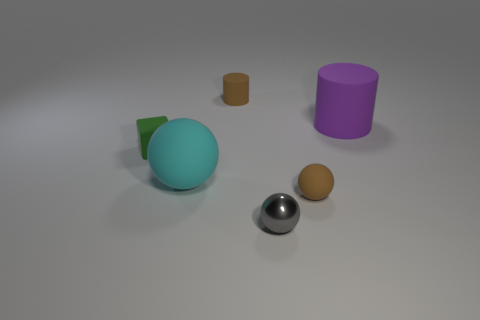Add 3 big cyan matte things. How many objects exist? 9 Subtract all cubes. How many objects are left? 5 Add 4 big purple matte cylinders. How many big purple matte cylinders are left? 5 Add 6 blue rubber objects. How many blue rubber objects exist? 6 Subtract 0 red cubes. How many objects are left? 6 Subtract all tiny green rubber blocks. Subtract all brown matte objects. How many objects are left? 3 